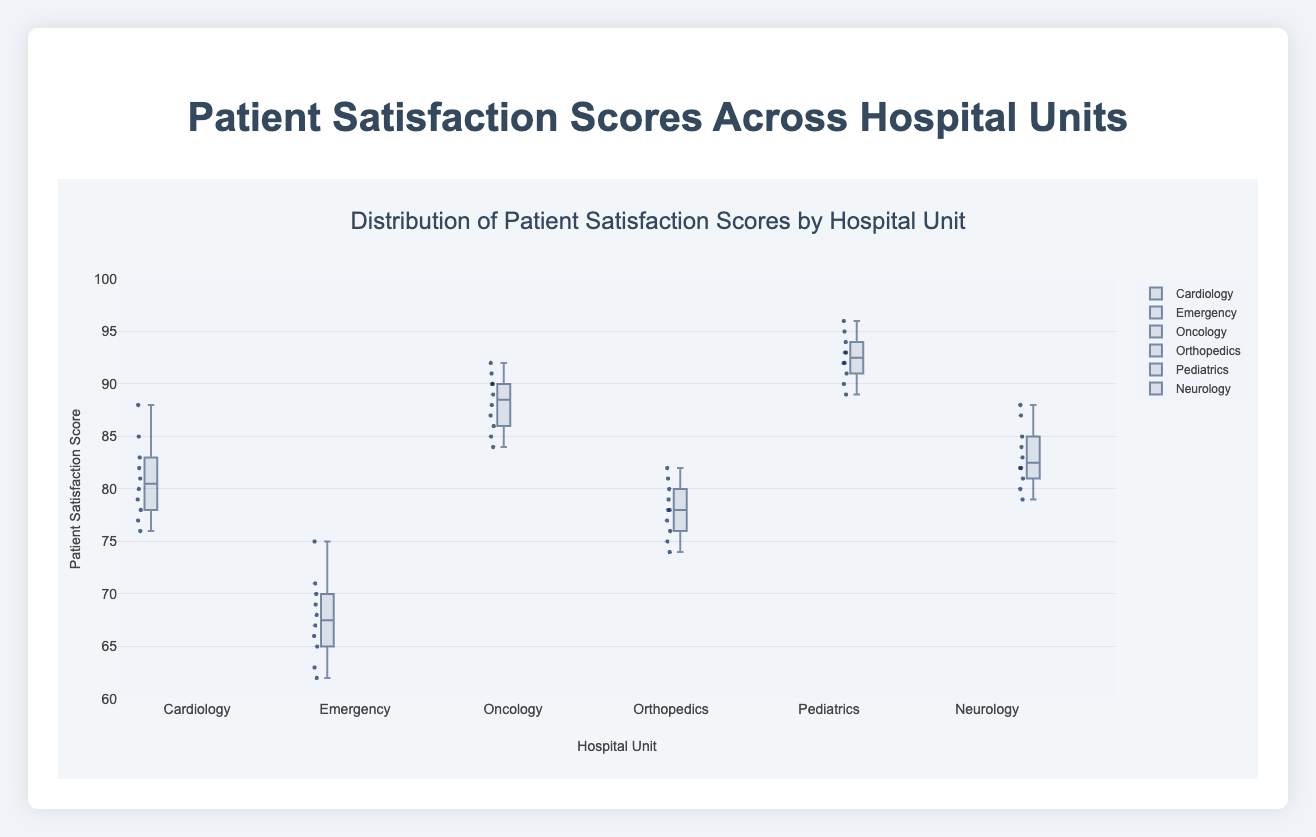What's the title of the figure? The title of the figure is written at the top and it states the main subject of the plot. The title of the figure is "Distribution of Patient Satisfaction Scores by Hospital Unit".
Answer: Distribution of Patient Satisfaction Scores by Hospital Unit Which hospital unit has the highest median patient satisfaction score? To find the highest median satisfaction score, compare the middle lines of the box plots of all units. The Pediatrics unit's box plot has the highest median line.
Answer: Pediatrics How many hospital units are represented in the figure? Count the number of distinct box plots, each representing a different hospital unit. There are six box plots, indicating six hospital units.
Answer: 6 What is the range of patient satisfaction scores in the Emergency unit? For the Emergency unit, find the lowest and highest ends of the box plot's whiskers. The whiskers for the Emergency unit go from 62 to 75.
Answer: 62 to 75 Which hospital unit has the lowest minimum patient satisfaction score? Locate the whisker extending to the lowest point on each plot. The Emergency unit has the lowest minimum score with a bottom whisker at 62.
Answer: Emergency What is the interquartile range (IQR) of the Oncology unit's patient satisfaction scores? The IQR is the distance between the 1st quartile (25th percentile) and the 3rd quartile (75th percentile). For Oncology, these values can be estimated from the box plot. The 1st quartile is around 87, and the 3rd quartile is around 90. So, the IQR is 90 - 87.
Answer: 3 Which hospital unit has the most variability in patient satisfaction scores? Variability can be judged by the range and spread of each box plot. The Emergency unit has the broadest range from the bottom to top whiskers, indicating the most variability.
Answer: Emergency Compare the median patient satisfaction scores of Cardiology and Neurology. Which unit has a higher median? Look at the middle line in the box plot for both units. The median for Cardiology is around 80, and for Neurology, it is also around 82. Neurology has a higher median.
Answer: Neurology What is the approximate median patient satisfaction score for the Orthopedics unit? Find the horizontal line within the box of the Orthopedics unit's box plot. The median value for Orthopedics is approximately 78.
Answer: 78 Is there any unit with a median patient satisfaction score above 90? Review the median lines in the box plots; only Pediatrics has a median line above 90.
Answer: Yes 